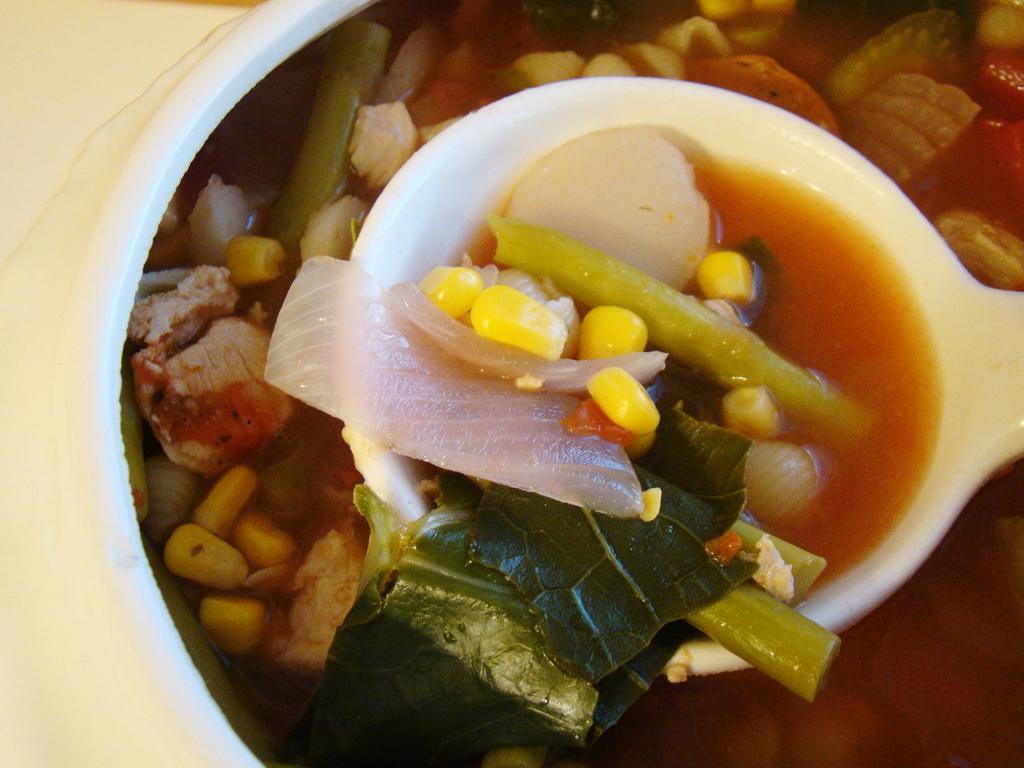Please provide a concise description of this image. In this image we can see food item and a spoon in the bowl. On the left side of the image there is a white surface. 